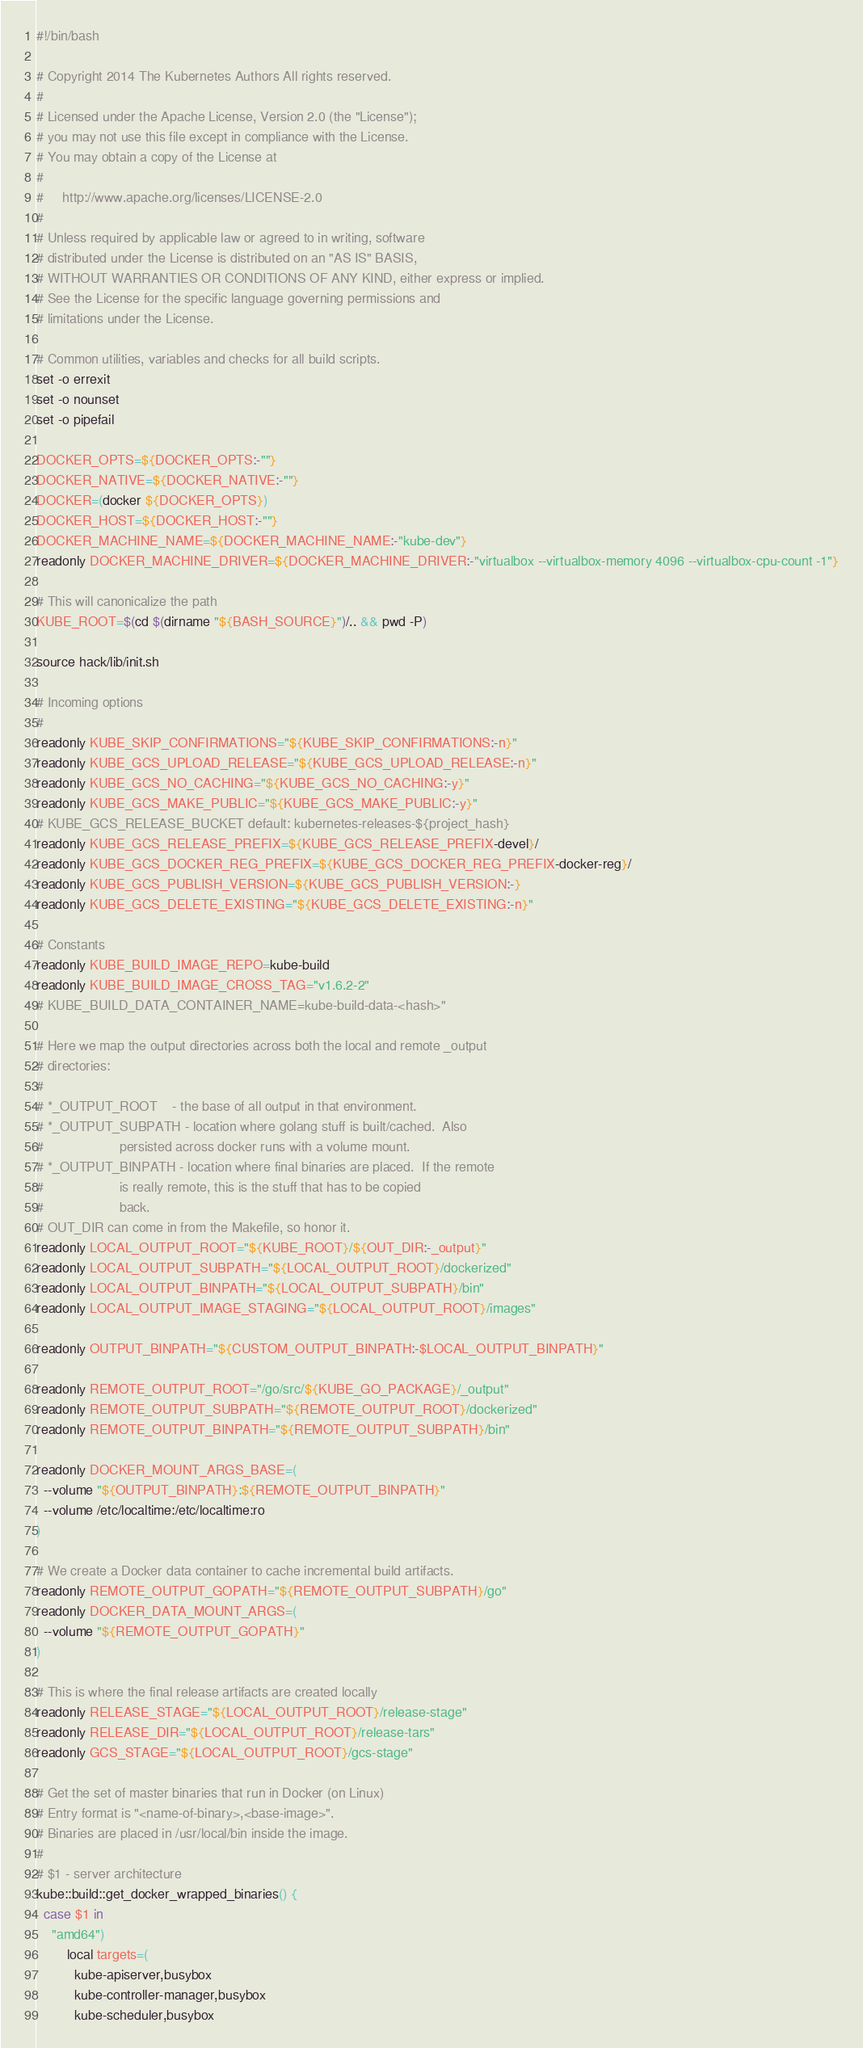Convert code to text. <code><loc_0><loc_0><loc_500><loc_500><_Bash_>#!/bin/bash

# Copyright 2014 The Kubernetes Authors All rights reserved.
#
# Licensed under the Apache License, Version 2.0 (the "License");
# you may not use this file except in compliance with the License.
# You may obtain a copy of the License at
#
#     http://www.apache.org/licenses/LICENSE-2.0
#
# Unless required by applicable law or agreed to in writing, software
# distributed under the License is distributed on an "AS IS" BASIS,
# WITHOUT WARRANTIES OR CONDITIONS OF ANY KIND, either express or implied.
# See the License for the specific language governing permissions and
# limitations under the License.

# Common utilities, variables and checks for all build scripts.
set -o errexit
set -o nounset
set -o pipefail

DOCKER_OPTS=${DOCKER_OPTS:-""}
DOCKER_NATIVE=${DOCKER_NATIVE:-""}
DOCKER=(docker ${DOCKER_OPTS})
DOCKER_HOST=${DOCKER_HOST:-""}
DOCKER_MACHINE_NAME=${DOCKER_MACHINE_NAME:-"kube-dev"}
readonly DOCKER_MACHINE_DRIVER=${DOCKER_MACHINE_DRIVER:-"virtualbox --virtualbox-memory 4096 --virtualbox-cpu-count -1"}

# This will canonicalize the path
KUBE_ROOT=$(cd $(dirname "${BASH_SOURCE}")/.. && pwd -P)

source hack/lib/init.sh

# Incoming options
#
readonly KUBE_SKIP_CONFIRMATIONS="${KUBE_SKIP_CONFIRMATIONS:-n}"
readonly KUBE_GCS_UPLOAD_RELEASE="${KUBE_GCS_UPLOAD_RELEASE:-n}"
readonly KUBE_GCS_NO_CACHING="${KUBE_GCS_NO_CACHING:-y}"
readonly KUBE_GCS_MAKE_PUBLIC="${KUBE_GCS_MAKE_PUBLIC:-y}"
# KUBE_GCS_RELEASE_BUCKET default: kubernetes-releases-${project_hash}
readonly KUBE_GCS_RELEASE_PREFIX=${KUBE_GCS_RELEASE_PREFIX-devel}/
readonly KUBE_GCS_DOCKER_REG_PREFIX=${KUBE_GCS_DOCKER_REG_PREFIX-docker-reg}/
readonly KUBE_GCS_PUBLISH_VERSION=${KUBE_GCS_PUBLISH_VERSION:-}
readonly KUBE_GCS_DELETE_EXISTING="${KUBE_GCS_DELETE_EXISTING:-n}"

# Constants
readonly KUBE_BUILD_IMAGE_REPO=kube-build
readonly KUBE_BUILD_IMAGE_CROSS_TAG="v1.6.2-2"
# KUBE_BUILD_DATA_CONTAINER_NAME=kube-build-data-<hash>"

# Here we map the output directories across both the local and remote _output
# directories:
#
# *_OUTPUT_ROOT    - the base of all output in that environment.
# *_OUTPUT_SUBPATH - location where golang stuff is built/cached.  Also
#                    persisted across docker runs with a volume mount.
# *_OUTPUT_BINPATH - location where final binaries are placed.  If the remote
#                    is really remote, this is the stuff that has to be copied
#                    back.
# OUT_DIR can come in from the Makefile, so honor it.
readonly LOCAL_OUTPUT_ROOT="${KUBE_ROOT}/${OUT_DIR:-_output}"
readonly LOCAL_OUTPUT_SUBPATH="${LOCAL_OUTPUT_ROOT}/dockerized"
readonly LOCAL_OUTPUT_BINPATH="${LOCAL_OUTPUT_SUBPATH}/bin"
readonly LOCAL_OUTPUT_IMAGE_STAGING="${LOCAL_OUTPUT_ROOT}/images"

readonly OUTPUT_BINPATH="${CUSTOM_OUTPUT_BINPATH:-$LOCAL_OUTPUT_BINPATH}"

readonly REMOTE_OUTPUT_ROOT="/go/src/${KUBE_GO_PACKAGE}/_output"
readonly REMOTE_OUTPUT_SUBPATH="${REMOTE_OUTPUT_ROOT}/dockerized"
readonly REMOTE_OUTPUT_BINPATH="${REMOTE_OUTPUT_SUBPATH}/bin"

readonly DOCKER_MOUNT_ARGS_BASE=(
  --volume "${OUTPUT_BINPATH}:${REMOTE_OUTPUT_BINPATH}"
  --volume /etc/localtime:/etc/localtime:ro
)

# We create a Docker data container to cache incremental build artifacts.
readonly REMOTE_OUTPUT_GOPATH="${REMOTE_OUTPUT_SUBPATH}/go"
readonly DOCKER_DATA_MOUNT_ARGS=(
  --volume "${REMOTE_OUTPUT_GOPATH}"
)

# This is where the final release artifacts are created locally
readonly RELEASE_STAGE="${LOCAL_OUTPUT_ROOT}/release-stage"
readonly RELEASE_DIR="${LOCAL_OUTPUT_ROOT}/release-tars"
readonly GCS_STAGE="${LOCAL_OUTPUT_ROOT}/gcs-stage"

# Get the set of master binaries that run in Docker (on Linux)
# Entry format is "<name-of-binary>,<base-image>".
# Binaries are placed in /usr/local/bin inside the image.
#
# $1 - server architecture
kube::build::get_docker_wrapped_binaries() {
  case $1 in
    "amd64")
        local targets=(
          kube-apiserver,busybox
          kube-controller-manager,busybox
          kube-scheduler,busybox</code> 